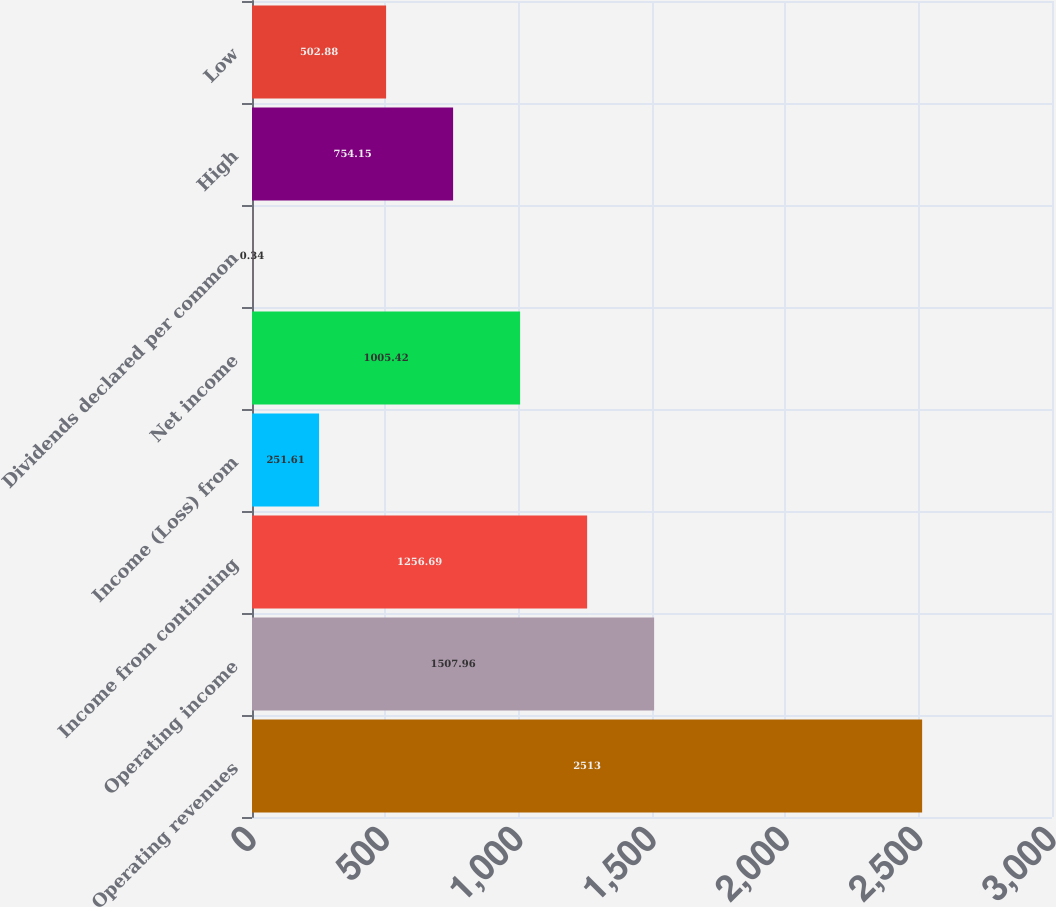Convert chart to OTSL. <chart><loc_0><loc_0><loc_500><loc_500><bar_chart><fcel>Operating revenues<fcel>Operating income<fcel>Income from continuing<fcel>Income (Loss) from<fcel>Net income<fcel>Dividends declared per common<fcel>High<fcel>Low<nl><fcel>2513<fcel>1507.96<fcel>1256.69<fcel>251.61<fcel>1005.42<fcel>0.34<fcel>754.15<fcel>502.88<nl></chart> 